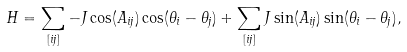<formula> <loc_0><loc_0><loc_500><loc_500>H = \sum _ { [ i j ] } - J \cos ( A _ { i j } ) \cos ( \theta _ { i } - \theta _ { j } ) + \sum _ { [ i j ] } J \sin ( A _ { i j } ) \sin ( \theta _ { i } - \theta _ { j } ) ,</formula> 